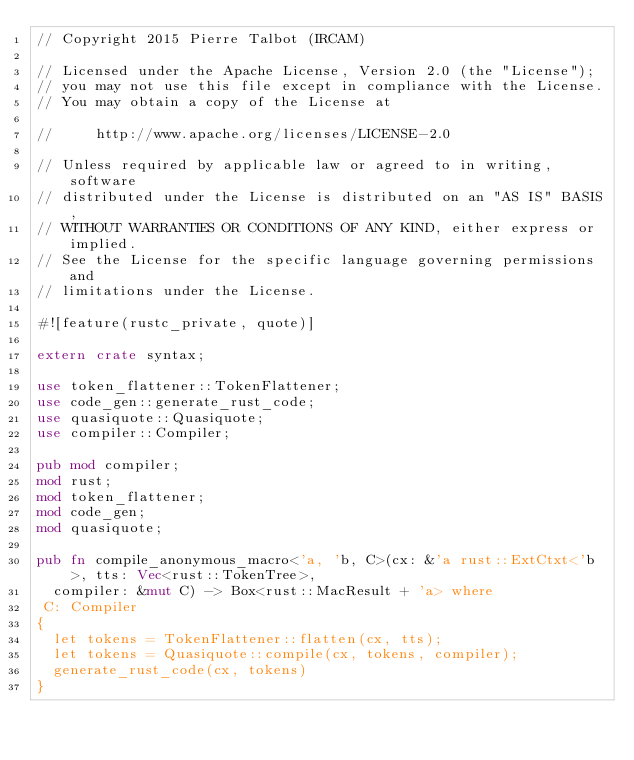Convert code to text. <code><loc_0><loc_0><loc_500><loc_500><_Rust_>// Copyright 2015 Pierre Talbot (IRCAM)

// Licensed under the Apache License, Version 2.0 (the "License");
// you may not use this file except in compliance with the License.
// You may obtain a copy of the License at

//     http://www.apache.org/licenses/LICENSE-2.0

// Unless required by applicable law or agreed to in writing, software
// distributed under the License is distributed on an "AS IS" BASIS,
// WITHOUT WARRANTIES OR CONDITIONS OF ANY KIND, either express or implied.
// See the License for the specific language governing permissions and
// limitations under the License.

#![feature(rustc_private, quote)]

extern crate syntax;

use token_flattener::TokenFlattener;
use code_gen::generate_rust_code;
use quasiquote::Quasiquote;
use compiler::Compiler;

pub mod compiler;
mod rust;
mod token_flattener;
mod code_gen;
mod quasiquote;

pub fn compile_anonymous_macro<'a, 'b, C>(cx: &'a rust::ExtCtxt<'b>, tts: Vec<rust::TokenTree>,
  compiler: &mut C) -> Box<rust::MacResult + 'a> where
 C: Compiler
{
  let tokens = TokenFlattener::flatten(cx, tts);
  let tokens = Quasiquote::compile(cx, tokens, compiler);
  generate_rust_code(cx, tokens)
}
</code> 